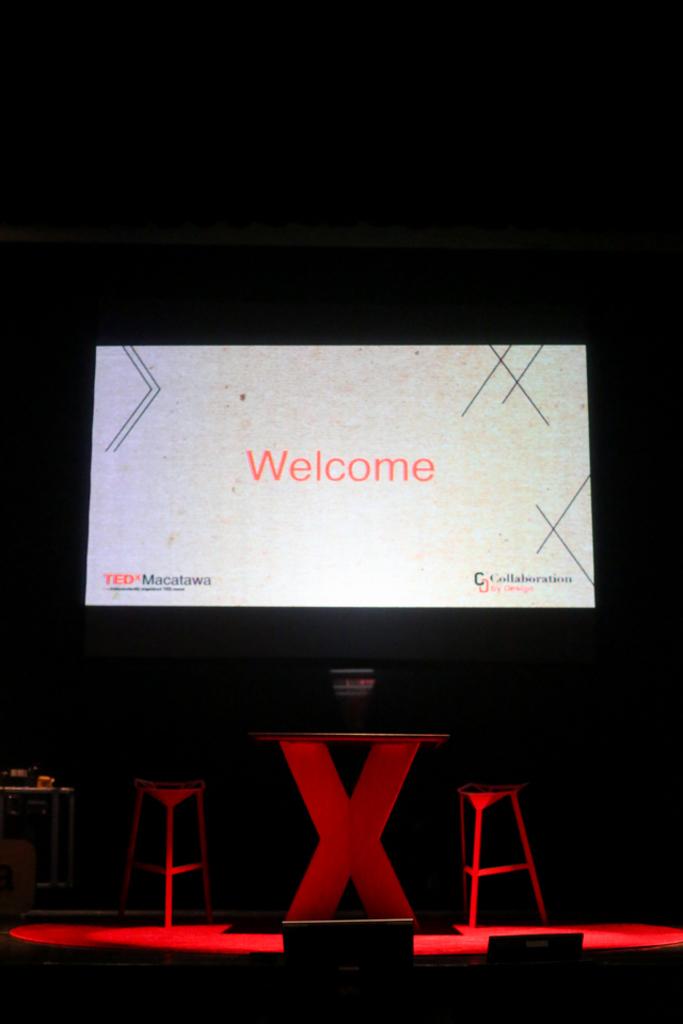Where is the conference being held?
Ensure brevity in your answer.  Unanswerable. Is the screen welcoming us?
Offer a terse response. Yes. 